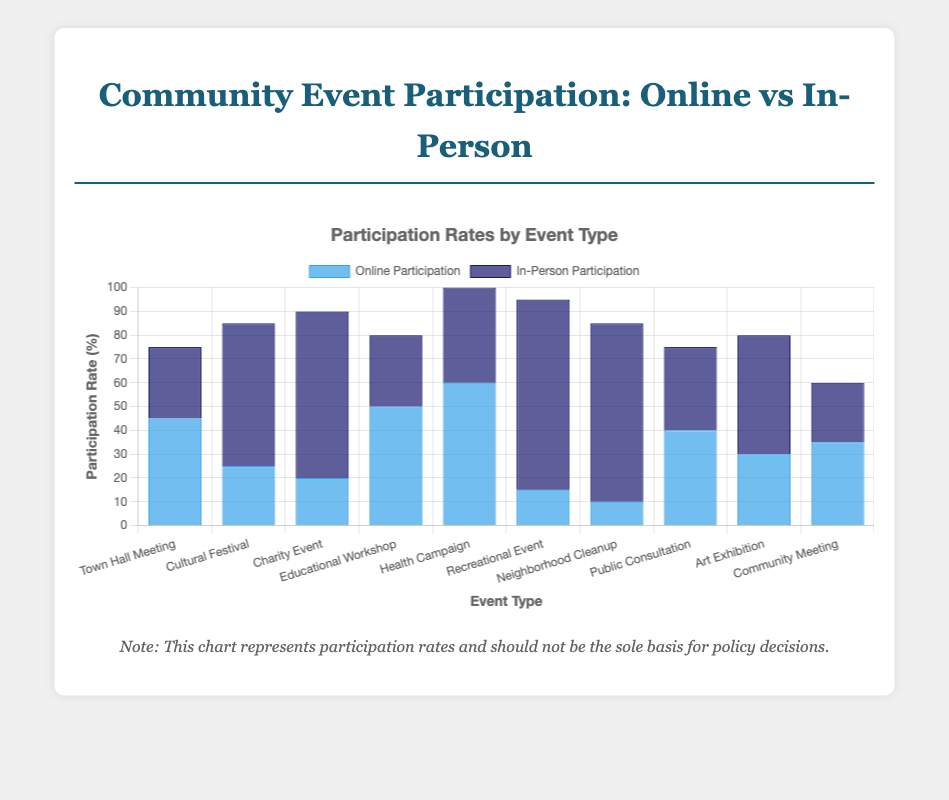Which event has the highest in-person participation rate? According to the chart, the event with the highest in-person participation rate is highlighted by the tallest dark blue bar. The tallest dark blue bar corresponds to the "Community Sports Day" event.
Answer: Community Sports Day Which event has the lowest online participation rate? The event with the lowest online participation rate can be identified by the shortest light blue bar. The shortest light blue bar corresponds to the "Annual Park Cleanup" event.
Answer: Annual Park Cleanup What is the total participation rate (online + in-person) for the "Mayor's Monthly Update"? To find the total participation rate for the "Mayor's Monthly Update" event, add the online participation rate (45) and the in-person participation rate (30). The sum is 45 + 30 = 75.
Answer: 75 Compare the online participation rate of the "Environmental Sustainability Workshop" to the "Vaccination Awareness Drive". Which is higher? The online participation rate for the "Environmental Sustainability Workshop" is 50, and for the "Vaccination Awareness Drive", it is 60. Since 60 is greater than 50, the "Vaccination Awareness Drive" has a higher online participation rate.
Answer: Vaccination Awareness Drive How many events have higher in-person participation rates than online participation rates? To determine this, compare the height of the dark blue bars to the light blue bars for all events. The events with higher in-person participation rates than online are: "Spring Cultural Fair", "Community Food Drive", "Community Sports Day", "Annual Park Cleanup", and "Local Artists Showcase". This gives us a total of 5 events.
Answer: 5 What’s the average in-person participation rate across all events? To find the average in-person participation rate, sum all in-person rates (30 + 60 + 70 + 30 + 40 + 80 + 75 + 35 + 50 + 25 = 495), then divide by the number of events (10). The average is 495 / 10 = 49.5.
Answer: 49.5 Compare the total participation rate between "District Budget Planning" and "City Development Plan Review". Which one is higher? To find the total participation rate, add online and in-person rates for each event. For "District Budget Planning": 35 (Online) + 25 (In-Person) = 60. For "City Development Plan Review": 40 (Online) + 35 (In-Person) = 75. Since 75 is greater than 60, "City Development Plan Review" has a higher total participation rate.
Answer: City Development Plan Review Which event has the smallest difference between online and in-person participation rates? The event with the smallest difference between online and in-person participation rates can be determined by finding the absolute difference between these rates for all events. The absolute differences are: 15, 35, 50, 20, 20, 65, 65, 5, 20, 10. The smallest difference is 5, corresponding to the "City Development Plan Review".
Answer: City Development Plan Review For the "Annual Park Cleanup", how does the online participation rate compare to in-person participation rate? The online participation rate for "Annual Park Cleanup" is 10, while the in-person participation rate is 75. Therefore, the in-person participation rate is significantly higher than the online rate.
Answer: In-person is higher What is the sum of in-person participation rates for all events categorized as "Educational Workshop" and "Health Campaign"? To find the sum, add the in-person participation rates of "Educational Workshop" (30) and "Health Campaign" (40). The sum is 30 + 40 = 70.
Answer: 70 